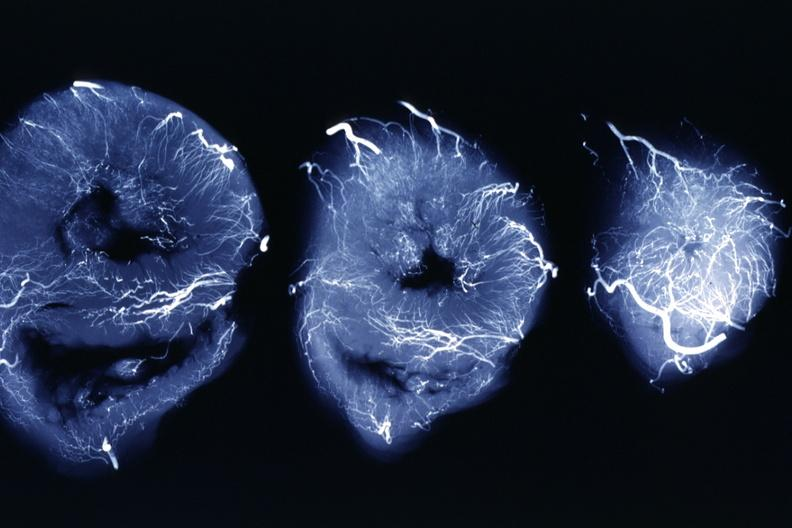s slices of liver and spleen typical tuberculous exudate is present on capsule of liver and spleen present?
Answer the question using a single word or phrase. No 